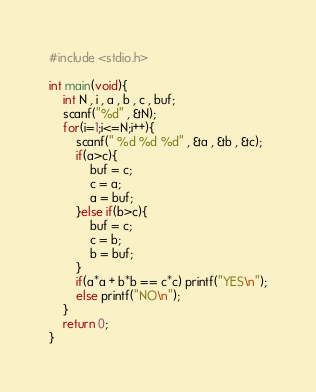<code> <loc_0><loc_0><loc_500><loc_500><_C_>#include <stdio.h>

int main(void){
	int N , i , a , b , c , buf;
	scanf("%d" , &N);
	for(i=1;i<=N;i++){
		scanf(" %d %d %d" , &a , &b , &c);
		if(a>c){
			buf = c;
			c = a;
			a = buf;
		}else if(b>c){
			buf = c;
			c = b;
			b = buf;
		}
		if(a*a + b*b == c*c) printf("YES\n");
		else printf("NO\n");
	}
	return 0;
}</code> 